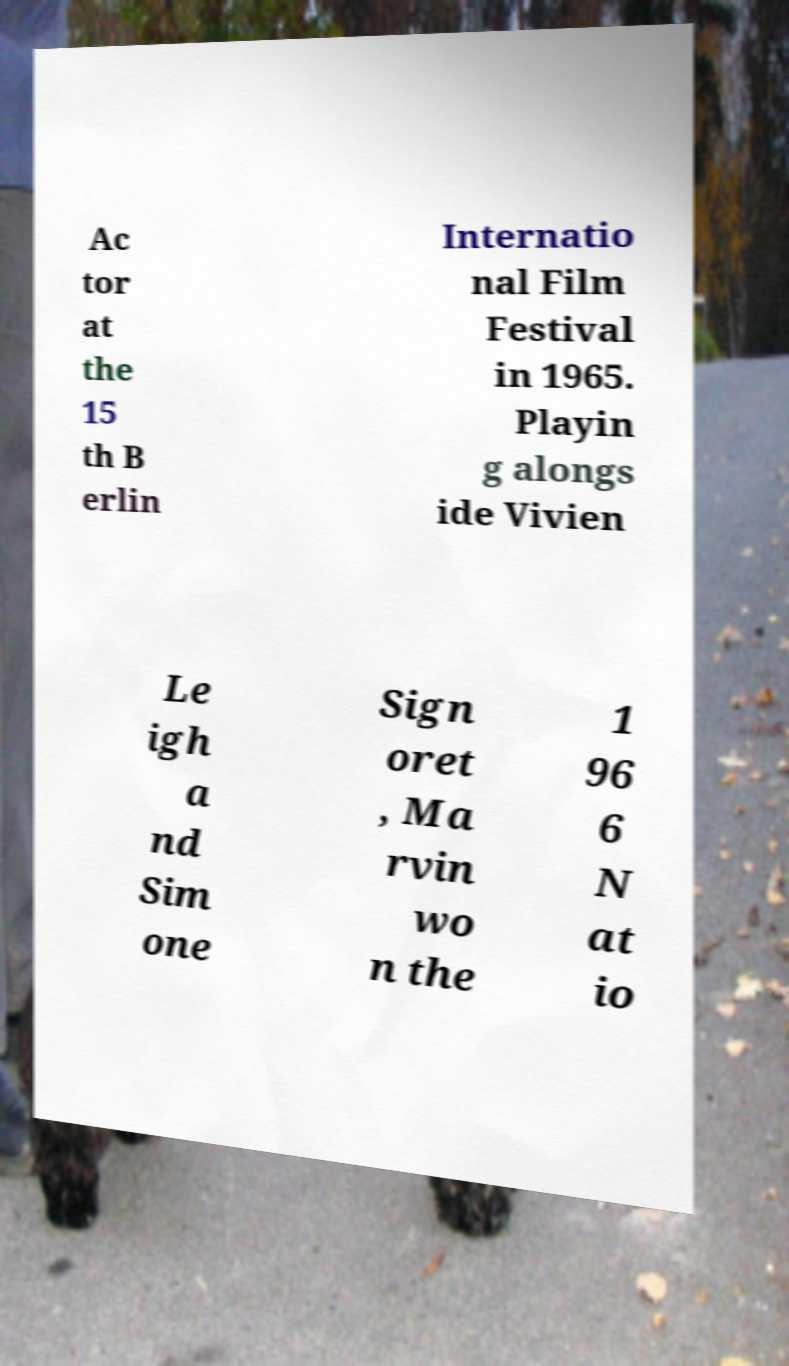What messages or text are displayed in this image? I need them in a readable, typed format. Ac tor at the 15 th B erlin Internatio nal Film Festival in 1965. Playin g alongs ide Vivien Le igh a nd Sim one Sign oret , Ma rvin wo n the 1 96 6 N at io 